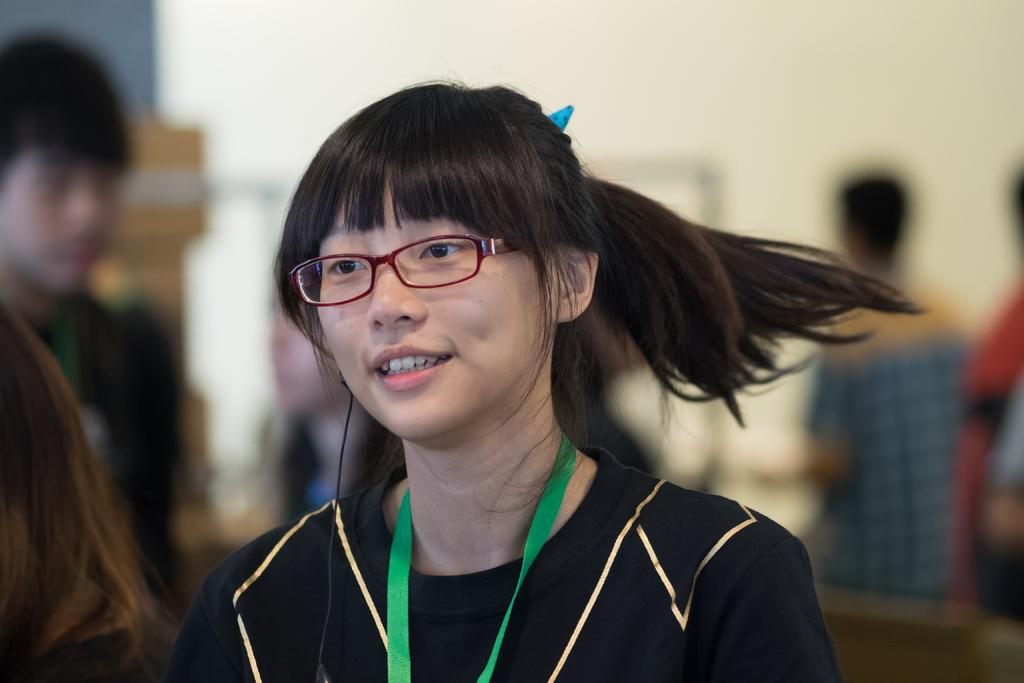Who is the main subject in the image? There is a lady in the center of the image. What is the lady wearing in the image? The lady is wearing spectacles. What can be seen in the background of the image? There are people and a wall in the background of the image. What type of beef is being served in the image? There is no beef present in the image. 